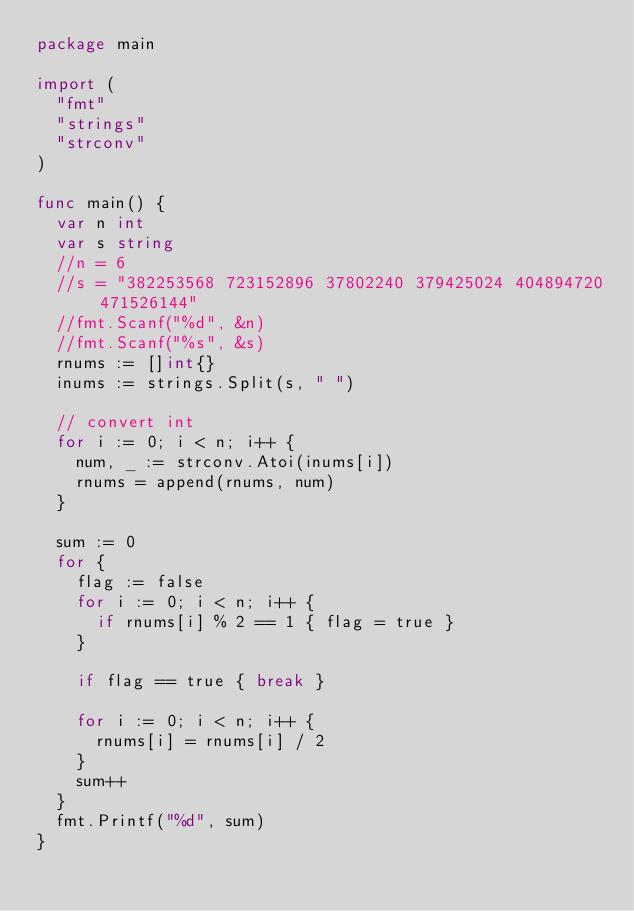<code> <loc_0><loc_0><loc_500><loc_500><_Go_>package main

import (
	"fmt"
	"strings"
	"strconv"
)

func main() {
	var n int
	var s string
	//n = 6
	//s = "382253568 723152896 37802240 379425024 404894720 471526144"
	//fmt.Scanf("%d", &n)
	//fmt.Scanf("%s", &s)
	rnums := []int{}
	inums := strings.Split(s, " ")

	// convert int
	for i := 0; i < n; i++ {
		num, _ := strconv.Atoi(inums[i])
		rnums = append(rnums, num)	
	}
	
	sum := 0
	for {
		flag := false
		for i := 0; i < n; i++ {
			if rnums[i] % 2 == 1 { flag = true }
		}

		if flag == true { break }

		for i := 0; i < n; i++ {
			rnums[i] = rnums[i] / 2
		}
		sum++
	}
	fmt.Printf("%d", sum)
}</code> 